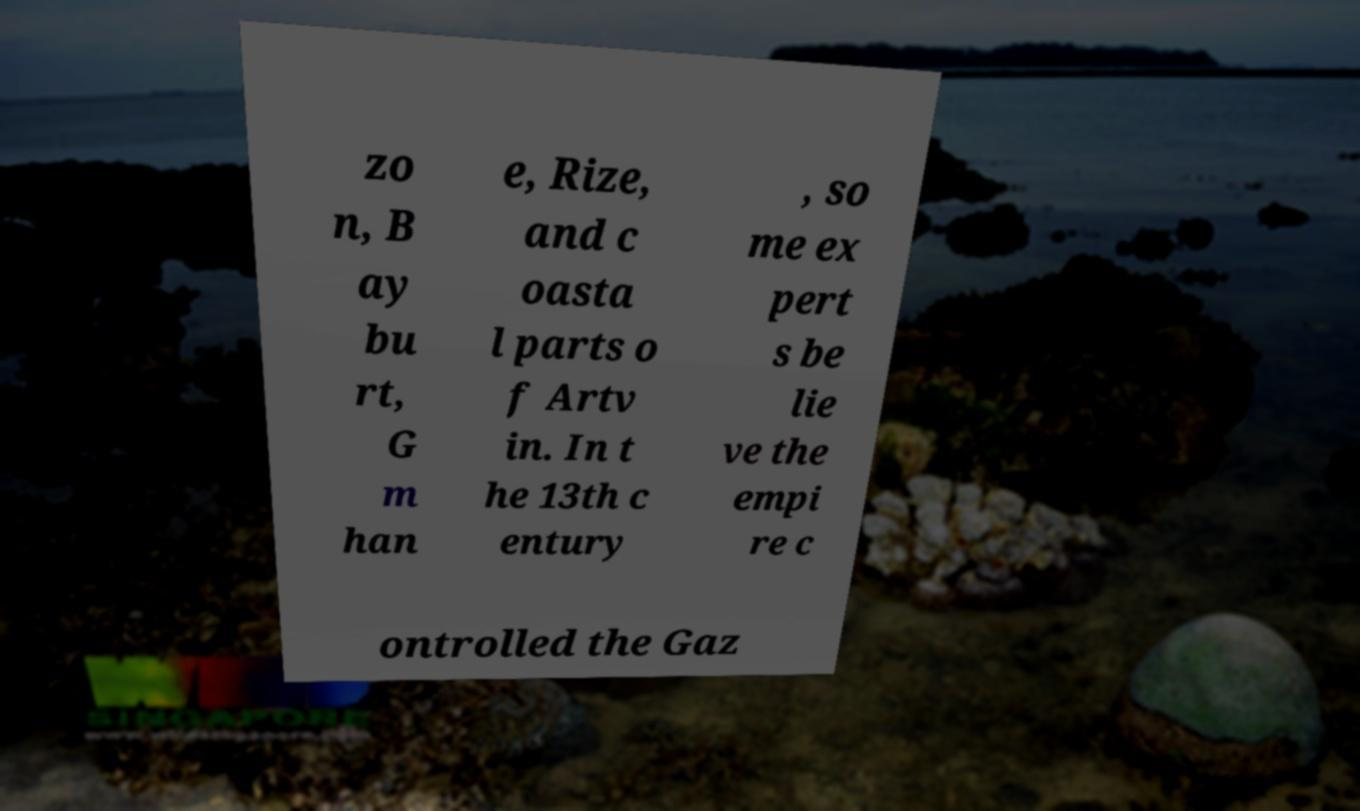I need the written content from this picture converted into text. Can you do that? zo n, B ay bu rt, G m han e, Rize, and c oasta l parts o f Artv in. In t he 13th c entury , so me ex pert s be lie ve the empi re c ontrolled the Gaz 